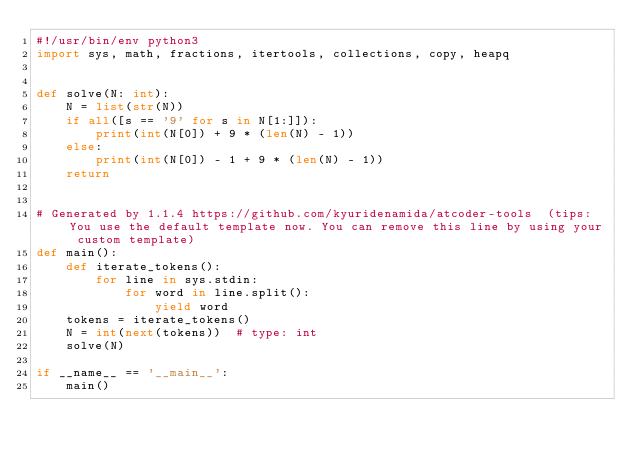<code> <loc_0><loc_0><loc_500><loc_500><_Python_>#!/usr/bin/env python3
import sys, math, fractions, itertools, collections, copy, heapq


def solve(N: int):
    N = list(str(N))
    if all([s == '9' for s in N[1:]]):
        print(int(N[0]) + 9 * (len(N) - 1))
    else:
        print(int(N[0]) - 1 + 9 * (len(N) - 1))
    return


# Generated by 1.1.4 https://github.com/kyuridenamida/atcoder-tools  (tips: You use the default template now. You can remove this line by using your custom template)
def main():
    def iterate_tokens():
        for line in sys.stdin:
            for word in line.split():
                yield word
    tokens = iterate_tokens()
    N = int(next(tokens))  # type: int
    solve(N)

if __name__ == '__main__':
    main()
</code> 